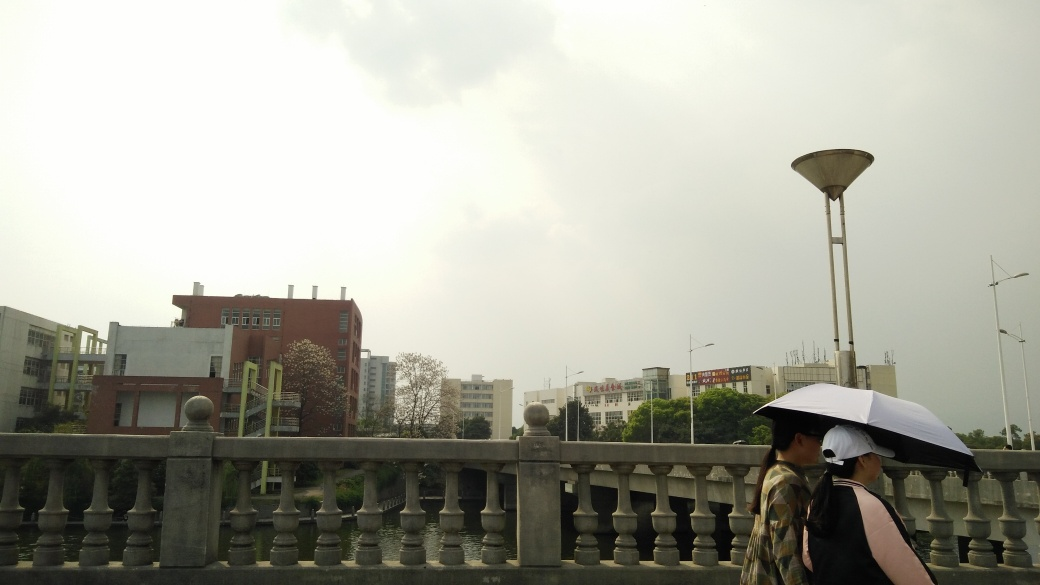What do the clothing and accessories of the individuals suggest about the climate or season? The individuals are dressed in long sleeves, and one is holding an umbrella, which suggests a cooler climate or a transitional season such as spring or autumn. The likelihood of rain, based on their preparedness with the umbrella, also indicates a wetter season or simply a rainy day. 